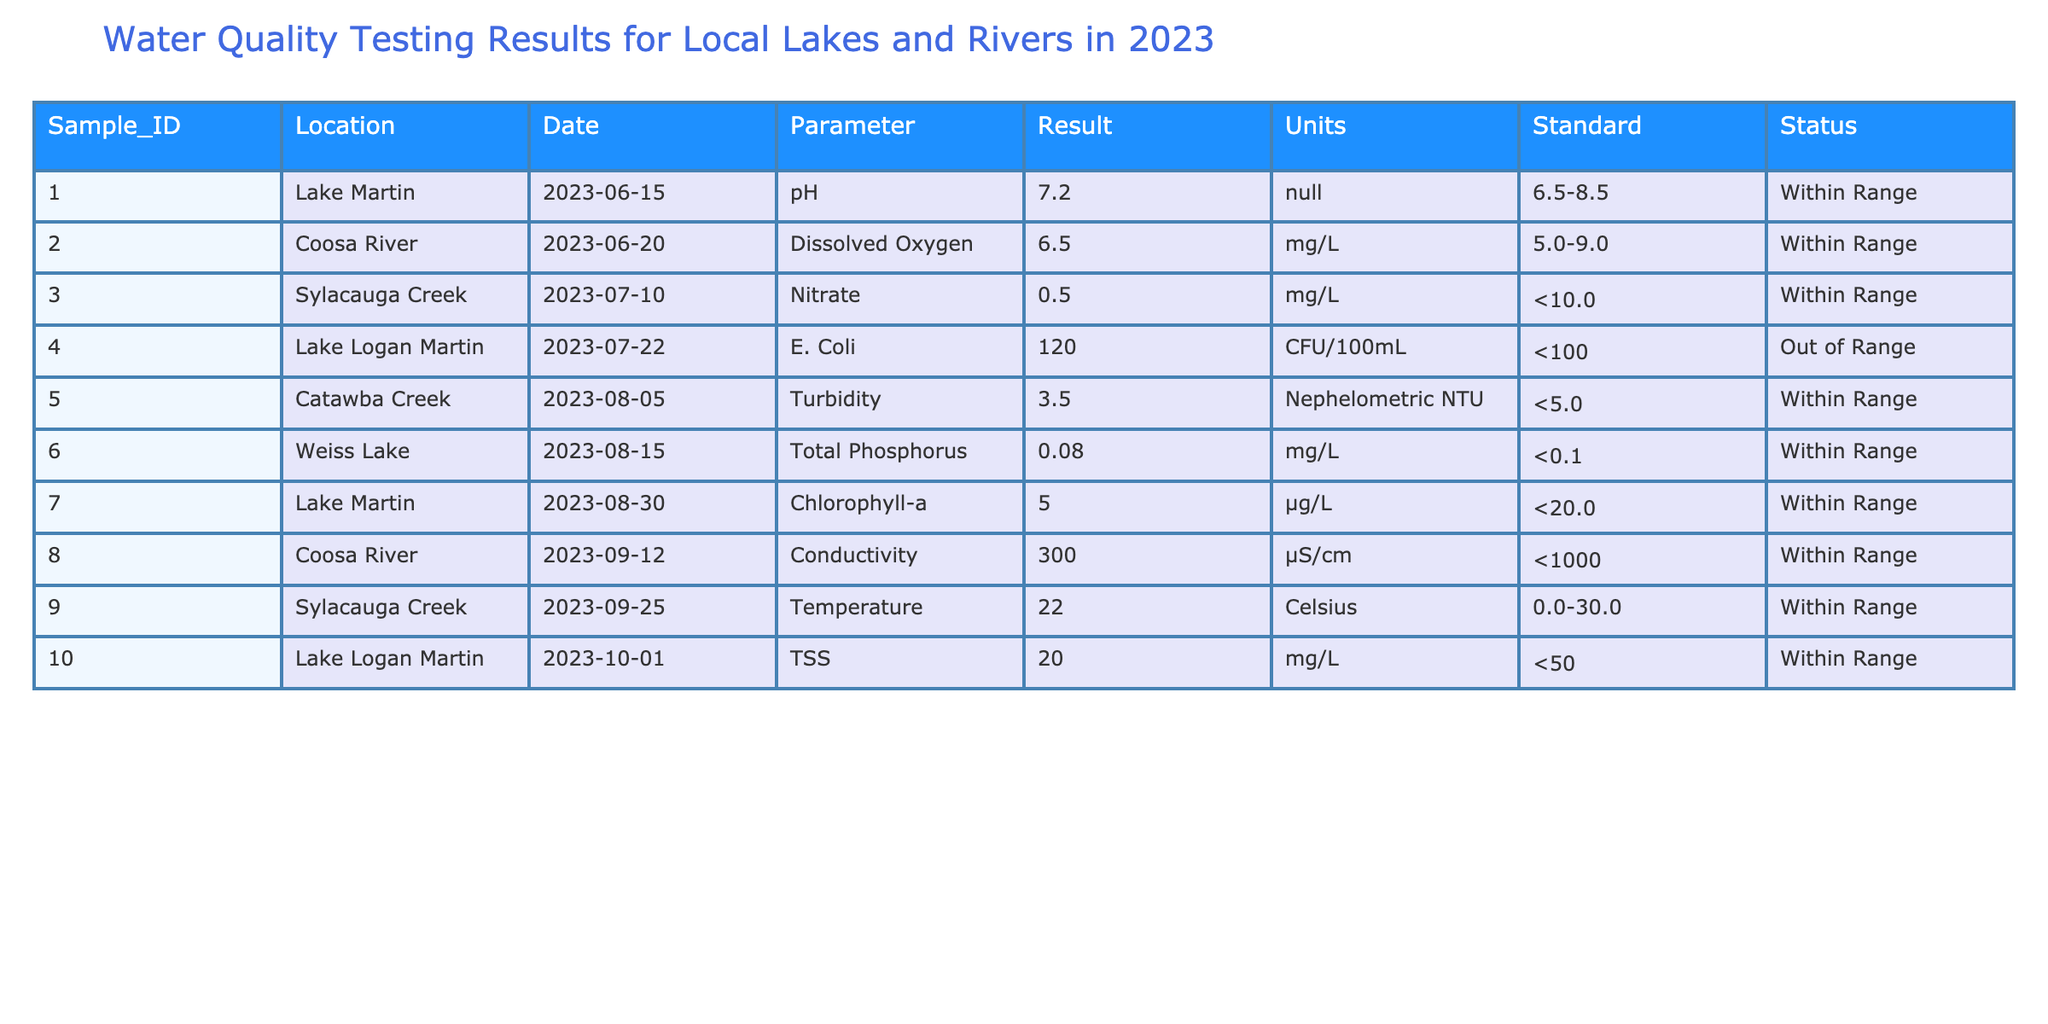What is the pH level recorded at Lake Martin? The table shows the value for the parameter pH at Lake Martin, found in the row with Sample_ID 001. The recorded pH level is 7.2.
Answer: 7.2 Which location recorded E. Coli levels that were out of range? By checking the E. Coli parameter in the entries, we see that Lake Logan Martin has a sample (Sample_ID 004) with an E. Coli level of 120 CFU/100mL, which is above the out of range standard of less than 100 CFU/100mL.
Answer: Lake Logan Martin What was the highest reported turbidity level and where was it recorded? Looking at the turbidity parameter, we find that Catawba Creek (Sample_ID 005) has a turbidity level of 3.5 NTU, which is the only reported turbidity level and thus the highest in this data set.
Answer: Catawba Creek, 3.5 NTU Is the temperature in Sylacauga Creek within the acceptable range? The temperature recorded for Sylacauga Creek is 22.0 Celsius, which falls within the acceptable standard range of 0.0-30.0 Celsius. Therefore, this parameter is considered within range.
Answer: Yes What is the average dissolved oxygen level from the table? The only dissolved oxygen level reported is from Coosa River (Sample_ID 002) with a result of 6.5 mg/L. Since there is only one data point, the average is also 6.5 mg/L.
Answer: 6.5 mg/L How many samples were tested for Total Phosphorus and what were their results? There is only one sample tested for Total Phosphorus (Sample_ID 006) with a recorded result of 0.08 mg/L. This means the total sample for this parameter is 1 and the result is 0.08 mg/L.
Answer: 1 sample, 0.08 mg/L How many parameters were tested for Lake Logan Martin? Two parameters are recorded for Lake Logan Martin: E. Coli (Sample_ID 004) and TSS (Sample_ID 010). This means the total number of tests for this location is 2.
Answer: 2 parameters Was any parameter at Weiss Lake found to be out of range? The parameter tested at Weiss Lake (Sample_ID 006) was Total Phosphorus, which had a result of 0.08 mg/L, falling within the acceptable limit of less than 0.1 mg/L, indicating no out of range issues.
Answer: No 